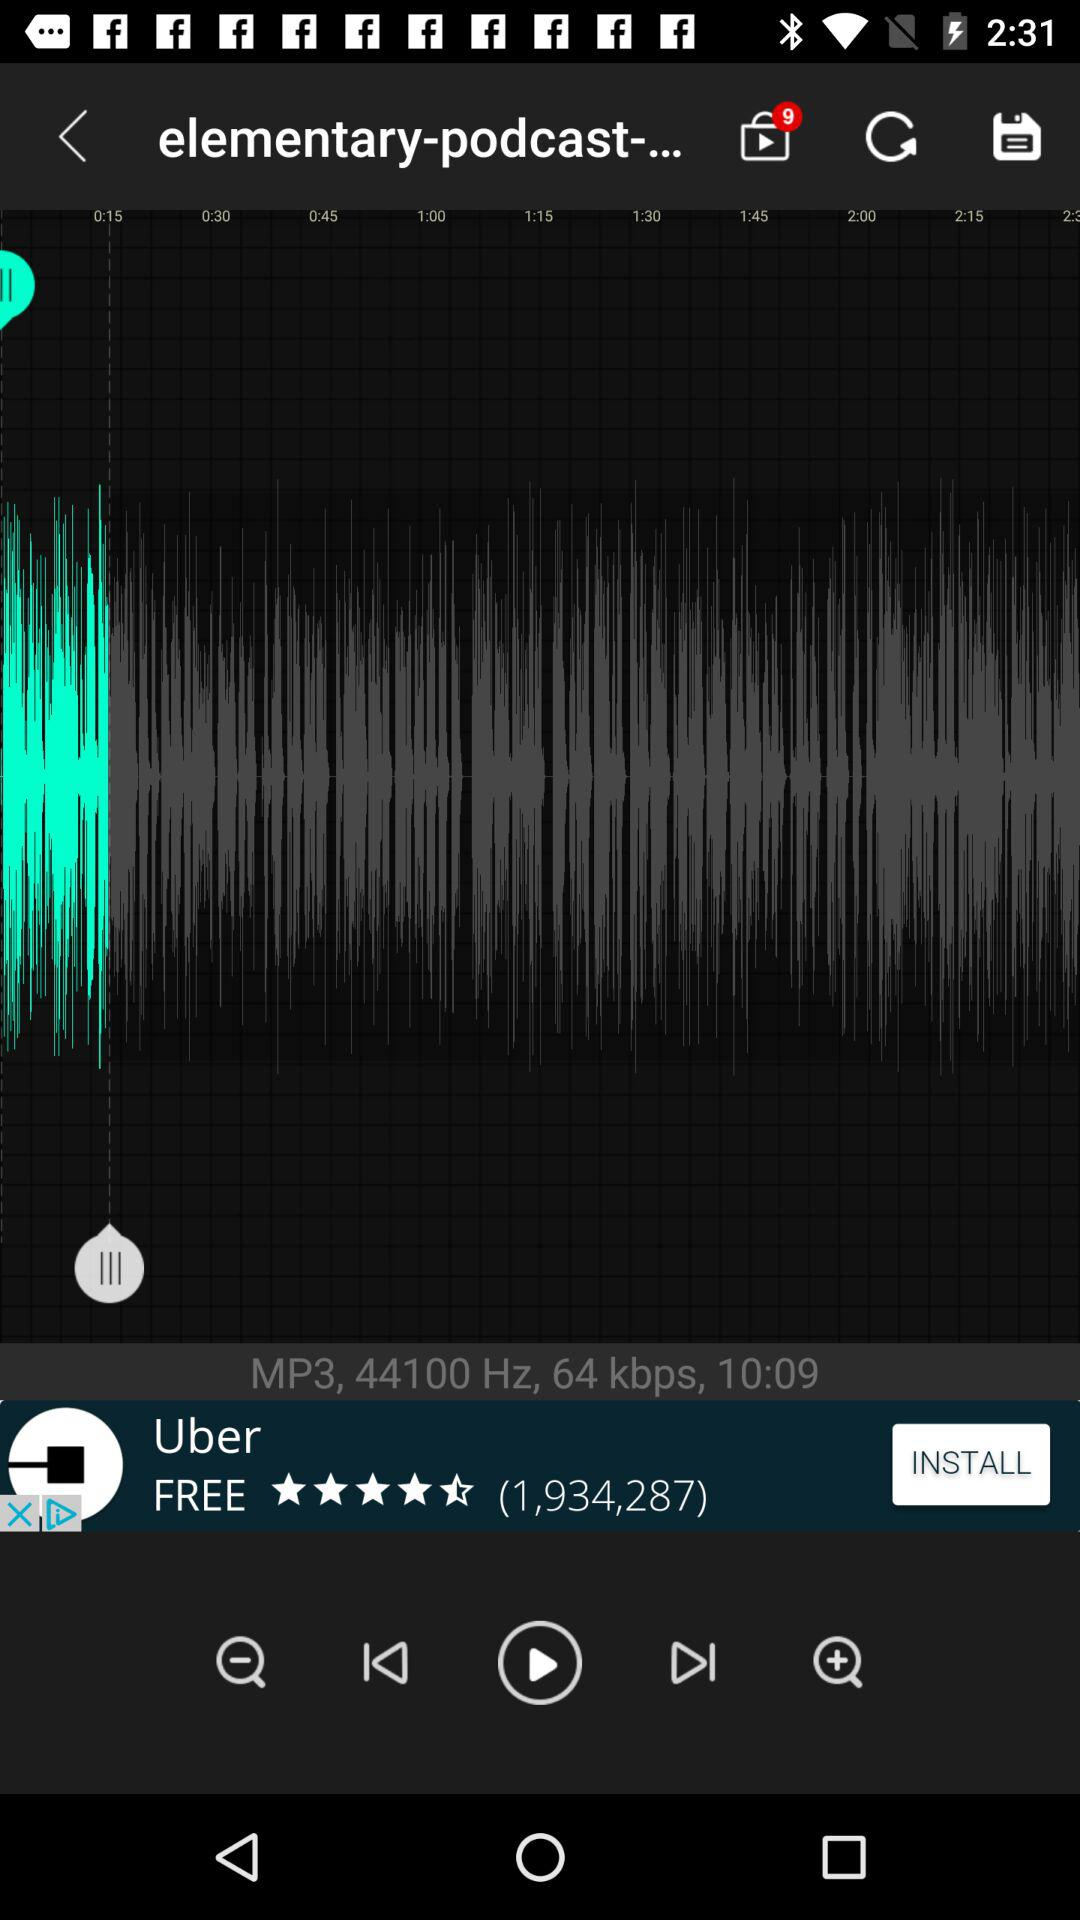What is the frequency? The frequency is 44100 Hz. 